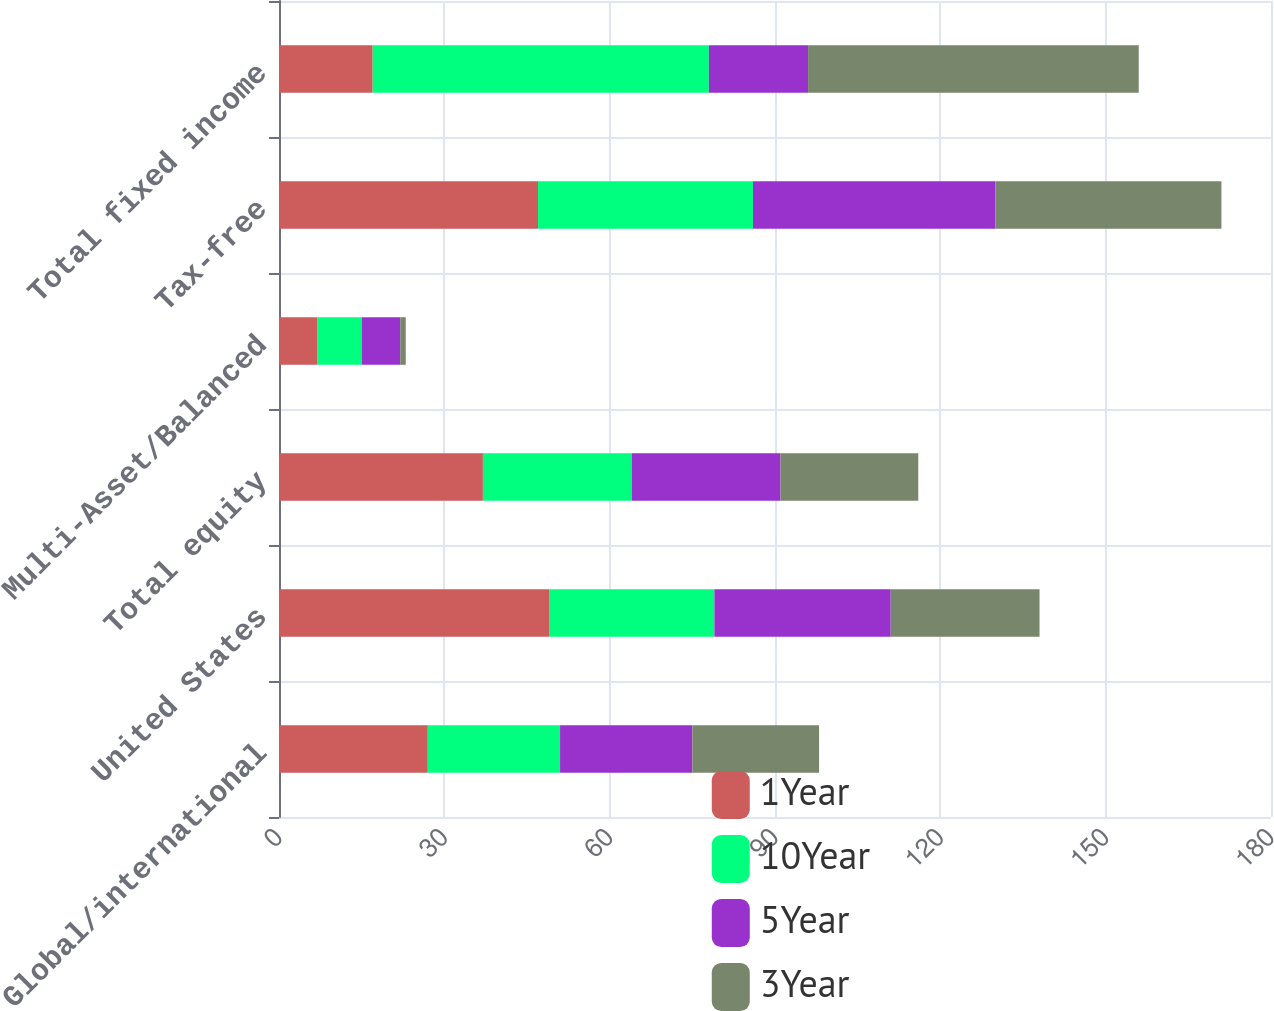Convert chart. <chart><loc_0><loc_0><loc_500><loc_500><stacked_bar_chart><ecel><fcel>Global/international<fcel>United States<fcel>Total equity<fcel>Multi-Asset/Balanced<fcel>Tax-free<fcel>Total fixed income<nl><fcel>1Year<fcel>27<fcel>49<fcel>37<fcel>7<fcel>47<fcel>17<nl><fcel>10Year<fcel>24<fcel>30<fcel>27<fcel>8<fcel>39<fcel>61<nl><fcel>5Year<fcel>24<fcel>32<fcel>27<fcel>7<fcel>44<fcel>18<nl><fcel>3Year<fcel>23<fcel>27<fcel>25<fcel>1<fcel>41<fcel>60<nl></chart> 